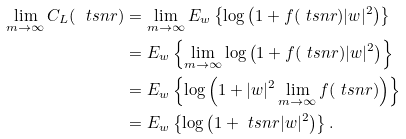Convert formula to latex. <formula><loc_0><loc_0><loc_500><loc_500>\lim _ { m \to \infty } C _ { L } ( \ t s n r ) & = \lim _ { m \to \infty } E _ { w } \left \{ \log \left ( 1 + f ( \ t s n r ) | w | ^ { 2 } \right ) \right \} \\ & = E _ { w } \left \{ \lim _ { m \to \infty } \log \left ( 1 + f ( \ t s n r ) | w | ^ { 2 } \right ) \right \} \\ & = E _ { w } \left \{ \log \left ( 1 + | w | ^ { 2 } \lim _ { m \to \infty } f ( \ t s n r ) \right ) \right \} \\ & = E _ { w } \left \{ \log \left ( 1 + \ t s n r | w | ^ { 2 } \right ) \right \} .</formula> 